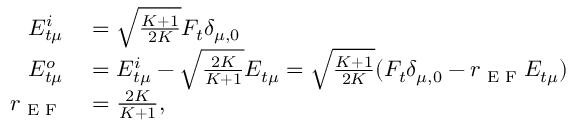Convert formula to latex. <formula><loc_0><loc_0><loc_500><loc_500>\begin{array} { r l } { E _ { t \mu } ^ { i } } & = \sqrt { \frac { K + 1 } { 2 K } } F _ { t } \delta _ { \mu , 0 } } \\ { E _ { t \mu } ^ { o } } & = E _ { t \mu } ^ { i } - \sqrt { \frac { 2 K } { K + 1 } } E _ { t \mu } = \sqrt { \frac { K + 1 } { 2 K } } ( F _ { t } \delta _ { \mu , 0 } - r _ { E F } E _ { t \mu } ) } \\ { r _ { E F } } & = \frac { 2 K } { K + 1 } , } \end{array}</formula> 